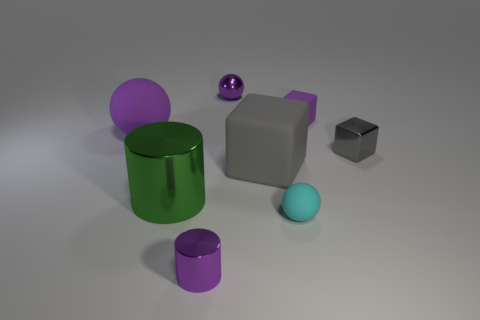Subtract all purple cubes. How many purple balls are left? 2 Subtract all purple spheres. How many spheres are left? 1 Add 2 small matte things. How many objects exist? 10 Subtract 1 balls. How many balls are left? 2 Subtract all spheres. How many objects are left? 5 Subtract all purple cubes. Subtract all small spheres. How many objects are left? 5 Add 8 metal cylinders. How many metal cylinders are left? 10 Add 4 green shiny things. How many green shiny things exist? 5 Subtract 0 gray balls. How many objects are left? 8 Subtract all blue cylinders. Subtract all cyan blocks. How many cylinders are left? 2 